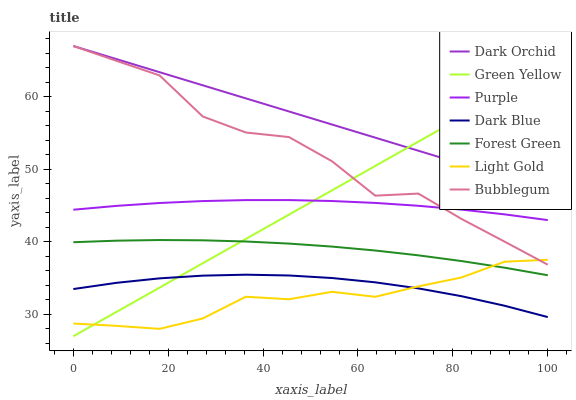Does Light Gold have the minimum area under the curve?
Answer yes or no. Yes. Does Dark Orchid have the maximum area under the curve?
Answer yes or no. Yes. Does Dark Blue have the minimum area under the curve?
Answer yes or no. No. Does Dark Blue have the maximum area under the curve?
Answer yes or no. No. Is Dark Orchid the smoothest?
Answer yes or no. Yes. Is Bubblegum the roughest?
Answer yes or no. Yes. Is Dark Blue the smoothest?
Answer yes or no. No. Is Dark Blue the roughest?
Answer yes or no. No. Does Green Yellow have the lowest value?
Answer yes or no. Yes. Does Dark Blue have the lowest value?
Answer yes or no. No. Does Bubblegum have the highest value?
Answer yes or no. Yes. Does Dark Blue have the highest value?
Answer yes or no. No. Is Dark Blue less than Dark Orchid?
Answer yes or no. Yes. Is Purple greater than Forest Green?
Answer yes or no. Yes. Does Light Gold intersect Forest Green?
Answer yes or no. Yes. Is Light Gold less than Forest Green?
Answer yes or no. No. Is Light Gold greater than Forest Green?
Answer yes or no. No. Does Dark Blue intersect Dark Orchid?
Answer yes or no. No. 